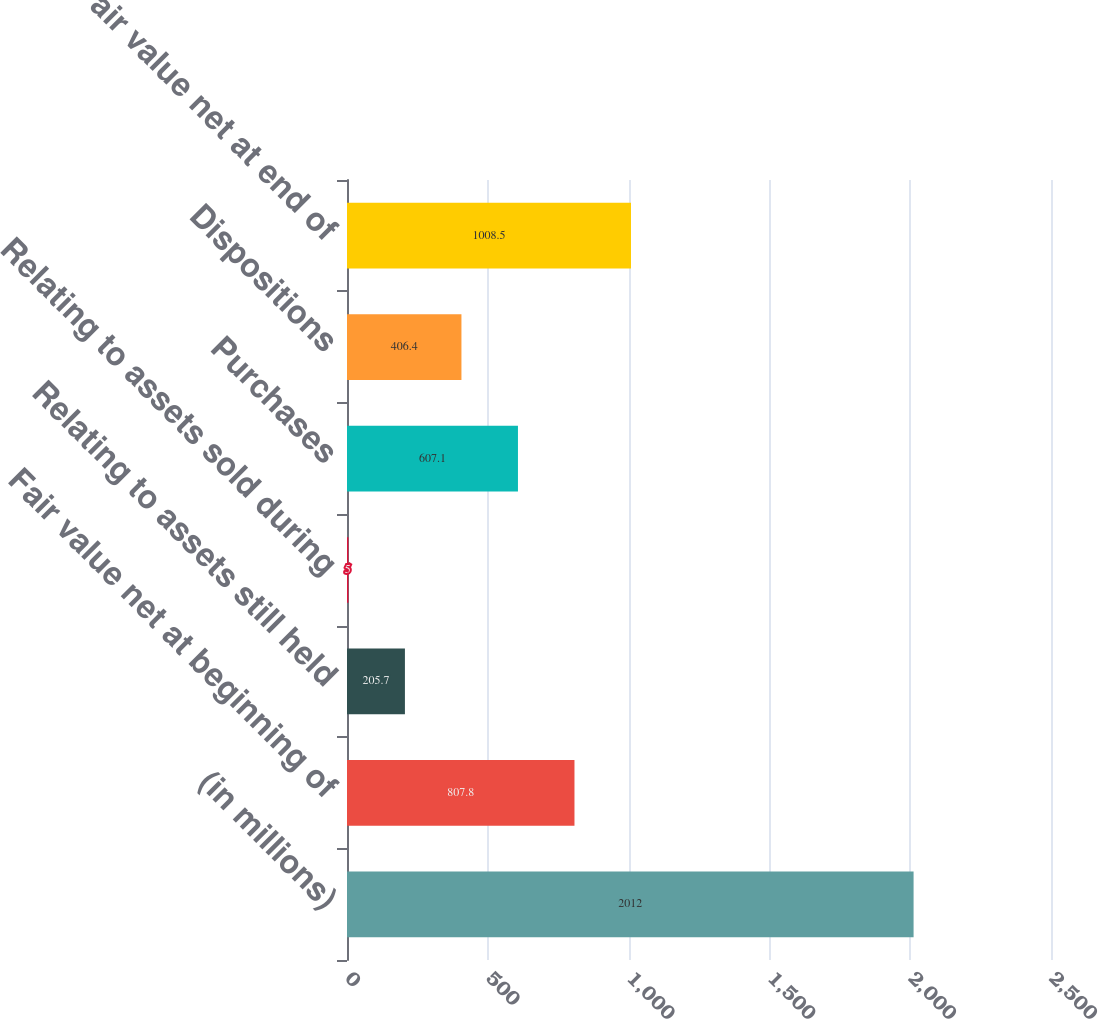Convert chart to OTSL. <chart><loc_0><loc_0><loc_500><loc_500><bar_chart><fcel>(in millions)<fcel>Fair value net at beginning of<fcel>Relating to assets still held<fcel>Relating to assets sold during<fcel>Purchases<fcel>Dispositions<fcel>Fair value net at end of<nl><fcel>2012<fcel>807.8<fcel>205.7<fcel>5<fcel>607.1<fcel>406.4<fcel>1008.5<nl></chart> 